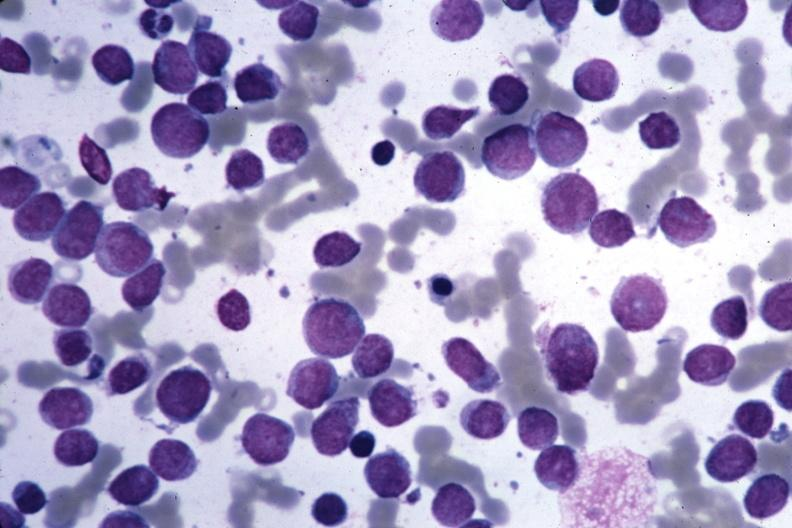what is present?
Answer the question using a single word or phrase. Acute myelogenous leukemia 